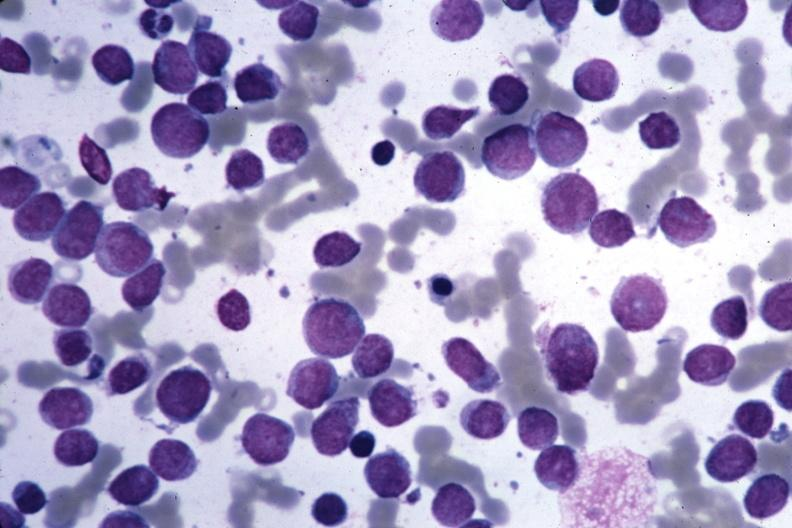what is present?
Answer the question using a single word or phrase. Acute myelogenous leukemia 